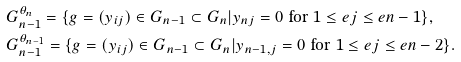Convert formula to latex. <formula><loc_0><loc_0><loc_500><loc_500>& G _ { n - 1 } ^ { \theta _ { n } } = \{ g = ( y _ { i j } ) \in G _ { n - 1 } \subset G _ { n } | y _ { n j } = 0 \text { for } 1 \leq e j \leq e n - 1 \} , \\ & G _ { n - 1 } ^ { \theta _ { n - 1 } } = \{ g = ( y _ { i j } ) \in G _ { n - 1 } \subset G _ { n } | y _ { n - 1 , j } = 0 \text { for } 1 \leq e j \leq e n - 2 \} .</formula> 